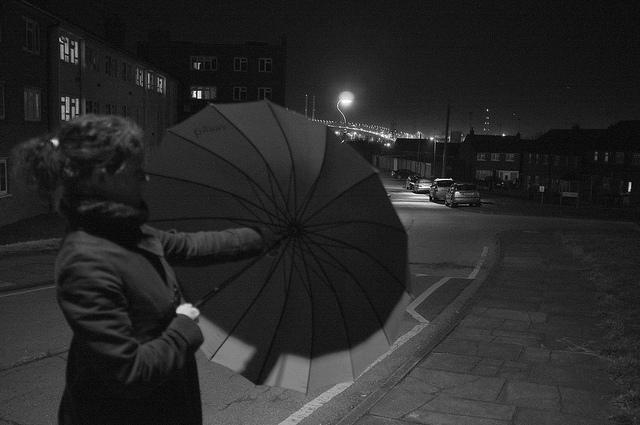How many apple iphones are there?
Give a very brief answer. 0. 